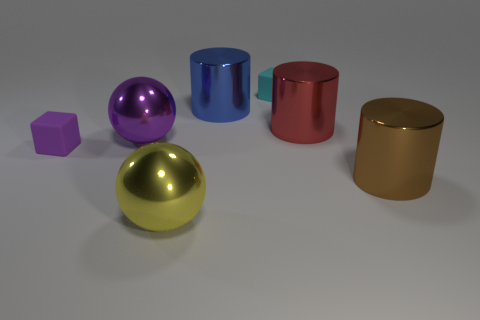What number of large blue metallic things are to the right of the shiny cylinder behind the red cylinder?
Your answer should be very brief. 0. Do the red shiny thing and the tiny purple object have the same shape?
Your answer should be compact. No. There is a big blue object; is its shape the same as the tiny thing left of the tiny cyan cube?
Your answer should be compact. No. The block that is behind the small rubber cube that is in front of the rubber block that is behind the big purple metallic ball is what color?
Ensure brevity in your answer.  Cyan. Is there any other thing that is made of the same material as the brown cylinder?
Your answer should be compact. Yes. Do the rubber thing that is left of the small cyan cube and the yellow metal thing have the same shape?
Your answer should be compact. No. What is the material of the small purple cube?
Give a very brief answer. Rubber. There is a red shiny thing behind the ball behind the large ball in front of the purple metallic object; what shape is it?
Offer a very short reply. Cylinder. How many other objects are there of the same shape as the big purple metal thing?
Your answer should be compact. 1. What number of red blocks are there?
Make the answer very short. 0. 